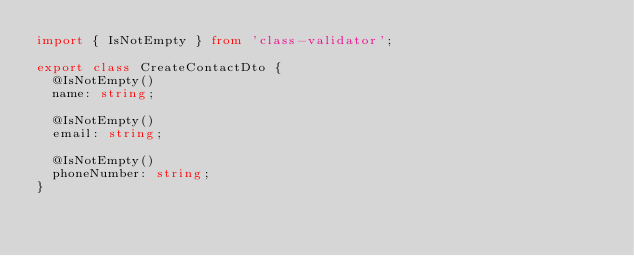Convert code to text. <code><loc_0><loc_0><loc_500><loc_500><_TypeScript_>import { IsNotEmpty } from 'class-validator';

export class CreateContactDto {
  @IsNotEmpty()
  name: string;

  @IsNotEmpty()
  email: string;
  
  @IsNotEmpty()
  phoneNumber: string;
}
</code> 